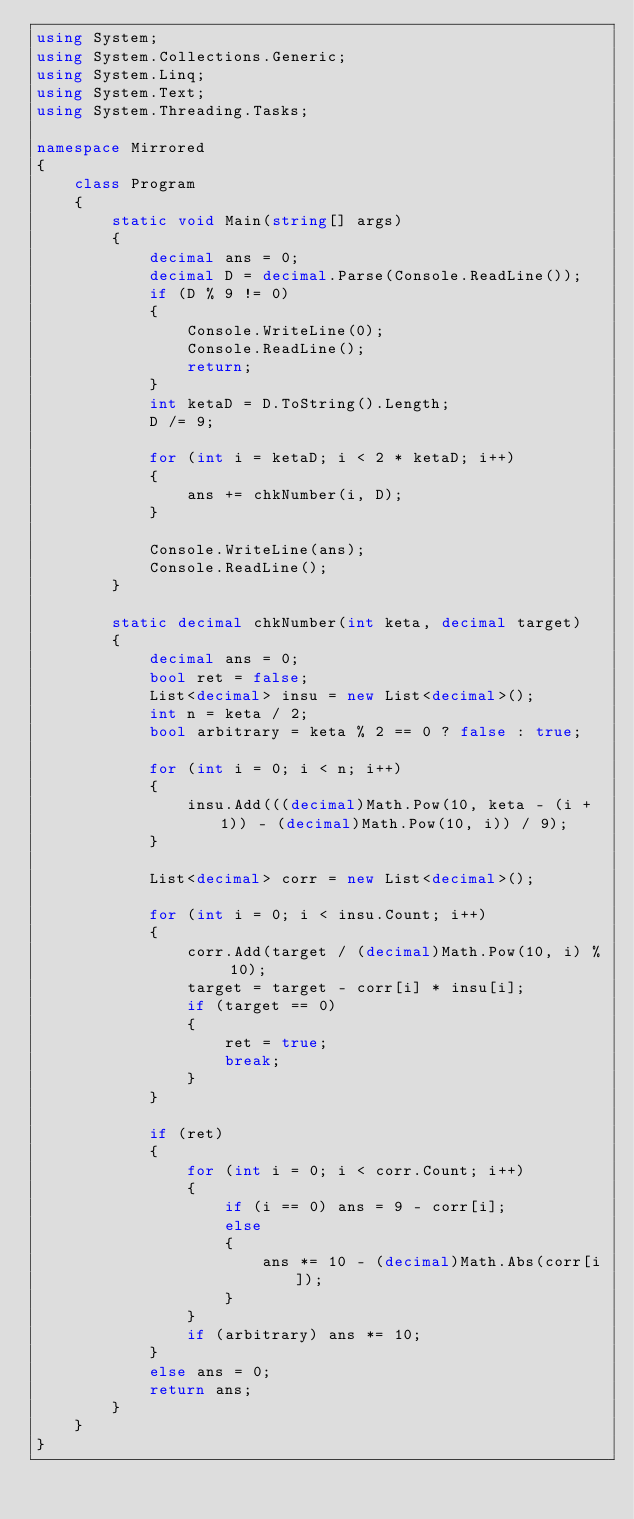Convert code to text. <code><loc_0><loc_0><loc_500><loc_500><_C#_>using System;
using System.Collections.Generic;
using System.Linq;
using System.Text;
using System.Threading.Tasks;

namespace Mirrored
{
    class Program
    {
        static void Main(string[] args)
        {
            decimal ans = 0;
            decimal D = decimal.Parse(Console.ReadLine());
            if (D % 9 != 0)
            {
                Console.WriteLine(0);
                Console.ReadLine();
                return;
            }
            int ketaD = D.ToString().Length;
            D /= 9;

            for (int i = ketaD; i < 2 * ketaD; i++)
            {
                ans += chkNumber(i, D);
            }

            Console.WriteLine(ans);
            Console.ReadLine();
        }

        static decimal chkNumber(int keta, decimal target)
        {
            decimal ans = 0;
            bool ret = false;
            List<decimal> insu = new List<decimal>();
            int n = keta / 2;
            bool arbitrary = keta % 2 == 0 ? false : true;

            for (int i = 0; i < n; i++)
            {
                insu.Add(((decimal)Math.Pow(10, keta - (i + 1)) - (decimal)Math.Pow(10, i)) / 9);
            }

            List<decimal> corr = new List<decimal>();

            for (int i = 0; i < insu.Count; i++)
            {
                corr.Add(target / (decimal)Math.Pow(10, i) % 10);
                target = target - corr[i] * insu[i];
                if (target == 0)
                {
                    ret = true;
                    break;
                }
            }

            if (ret)
            {
                for (int i = 0; i < corr.Count; i++)
                {
                    if (i == 0) ans = 9 - corr[i];
                    else
                    {
                        ans *= 10 - (decimal)Math.Abs(corr[i]);
                    }
                }
                if (arbitrary) ans *= 10;
            }
            else ans = 0;
            return ans;
        }
    }
}
</code> 